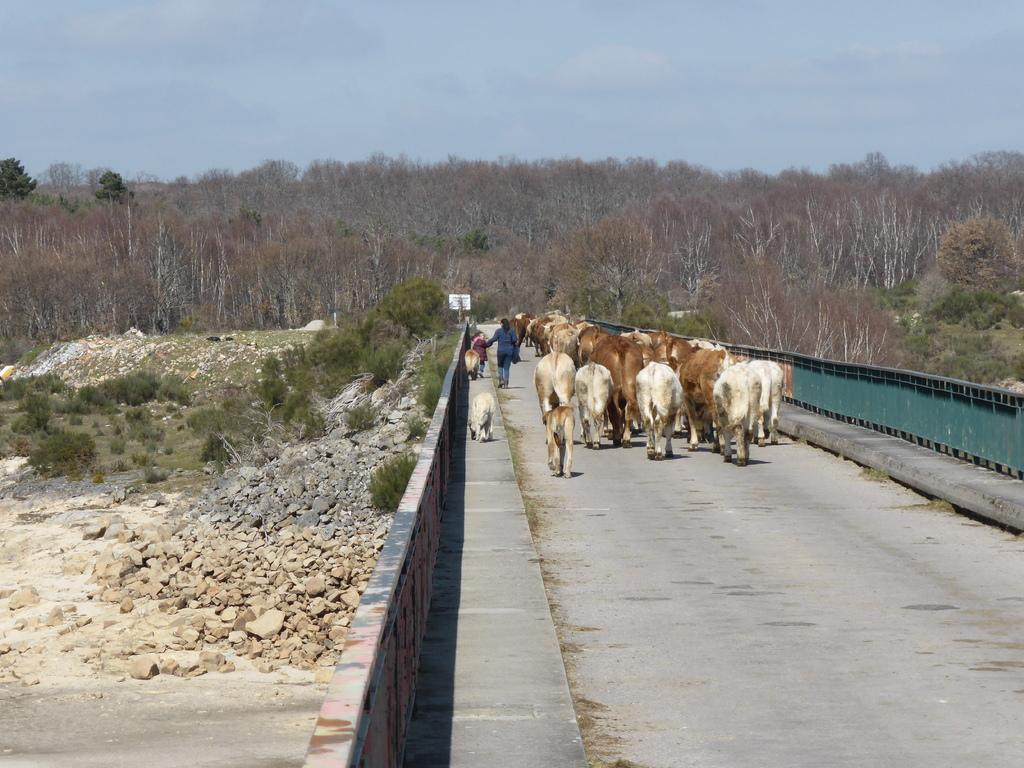What is the person in the image doing? There is a person walking in the image. What else can be seen on the road in the image? There are animals on the road in the image. What is located near the road in the image? There is a fence in the image. What type of vegetation is present in the image? There are plants in the image. What object can be seen in the image that might be used for displaying information? There is a board in the image. What type of ground surface is visible in the image? There are stones in the image. What can be seen in the distance in the image? There are trees visible in the background of the image. What else is visible in the background of the image? The sky is visible in the background of the image. What word is written on the business sign in the image? There is no business sign present in the image. 